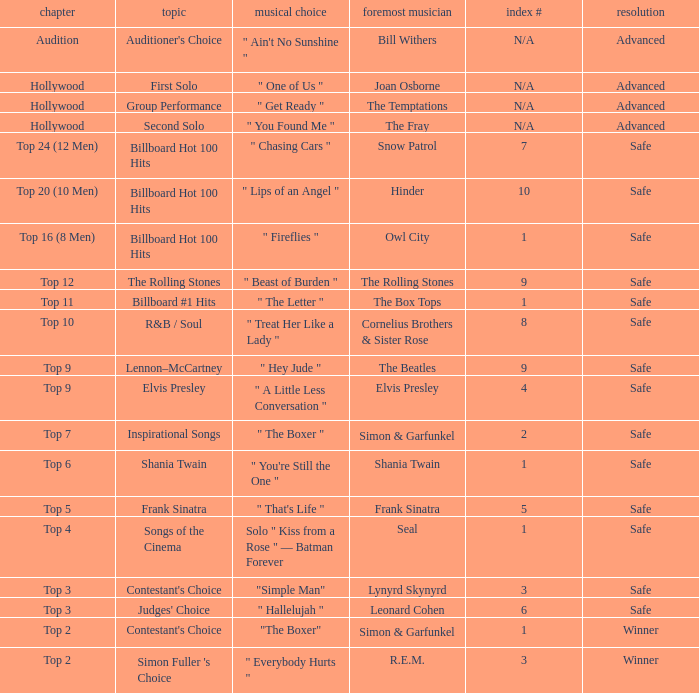Would you be able to parse every entry in this table? {'header': ['chapter', 'topic', 'musical choice', 'foremost musician', 'index #', 'resolution'], 'rows': [['Audition', "Auditioner's Choice", '" Ain\'t No Sunshine "', 'Bill Withers', 'N/A', 'Advanced'], ['Hollywood', 'First Solo', '" One of Us "', 'Joan Osborne', 'N/A', 'Advanced'], ['Hollywood', 'Group Performance', '" Get Ready "', 'The Temptations', 'N/A', 'Advanced'], ['Hollywood', 'Second Solo', '" You Found Me "', 'The Fray', 'N/A', 'Advanced'], ['Top 24 (12 Men)', 'Billboard Hot 100 Hits', '" Chasing Cars "', 'Snow Patrol', '7', 'Safe'], ['Top 20 (10 Men)', 'Billboard Hot 100 Hits', '" Lips of an Angel "', 'Hinder', '10', 'Safe'], ['Top 16 (8 Men)', 'Billboard Hot 100 Hits', '" Fireflies "', 'Owl City', '1', 'Safe'], ['Top 12', 'The Rolling Stones', '" Beast of Burden "', 'The Rolling Stones', '9', 'Safe'], ['Top 11', 'Billboard #1 Hits', '" The Letter "', 'The Box Tops', '1', 'Safe'], ['Top 10', 'R&B / Soul', '" Treat Her Like a Lady "', 'Cornelius Brothers & Sister Rose', '8', 'Safe'], ['Top 9', 'Lennon–McCartney', '" Hey Jude "', 'The Beatles', '9', 'Safe'], ['Top 9', 'Elvis Presley', '" A Little Less Conversation "', 'Elvis Presley', '4', 'Safe'], ['Top 7', 'Inspirational Songs', '" The Boxer "', 'Simon & Garfunkel', '2', 'Safe'], ['Top 6', 'Shania Twain', '" You\'re Still the One "', 'Shania Twain', '1', 'Safe'], ['Top 5', 'Frank Sinatra', '" That\'s Life "', 'Frank Sinatra', '5', 'Safe'], ['Top 4', 'Songs of the Cinema', 'Solo " Kiss from a Rose " — Batman Forever', 'Seal', '1', 'Safe'], ['Top 3', "Contestant's Choice", '"Simple Man"', 'Lynyrd Skynyrd', '3', 'Safe'], ['Top 3', "Judges' Choice", '" Hallelujah "', 'Leonard Cohen', '6', 'Safe'], ['Top 2', "Contestant's Choice", '"The Boxer"', 'Simon & Garfunkel', '1', 'Winner'], ['Top 2', "Simon Fuller 's Choice", '" Everybody Hurts "', 'R.E.M.', '3', 'Winner']]} The song choice " One of Us " has what themes? First Solo. 